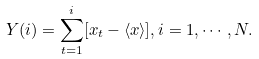Convert formula to latex. <formula><loc_0><loc_0><loc_500><loc_500>Y ( i ) = \sum _ { t = 1 } ^ { i } [ x _ { t } - \langle x \rangle ] , i = 1 , \cdots , N .</formula> 